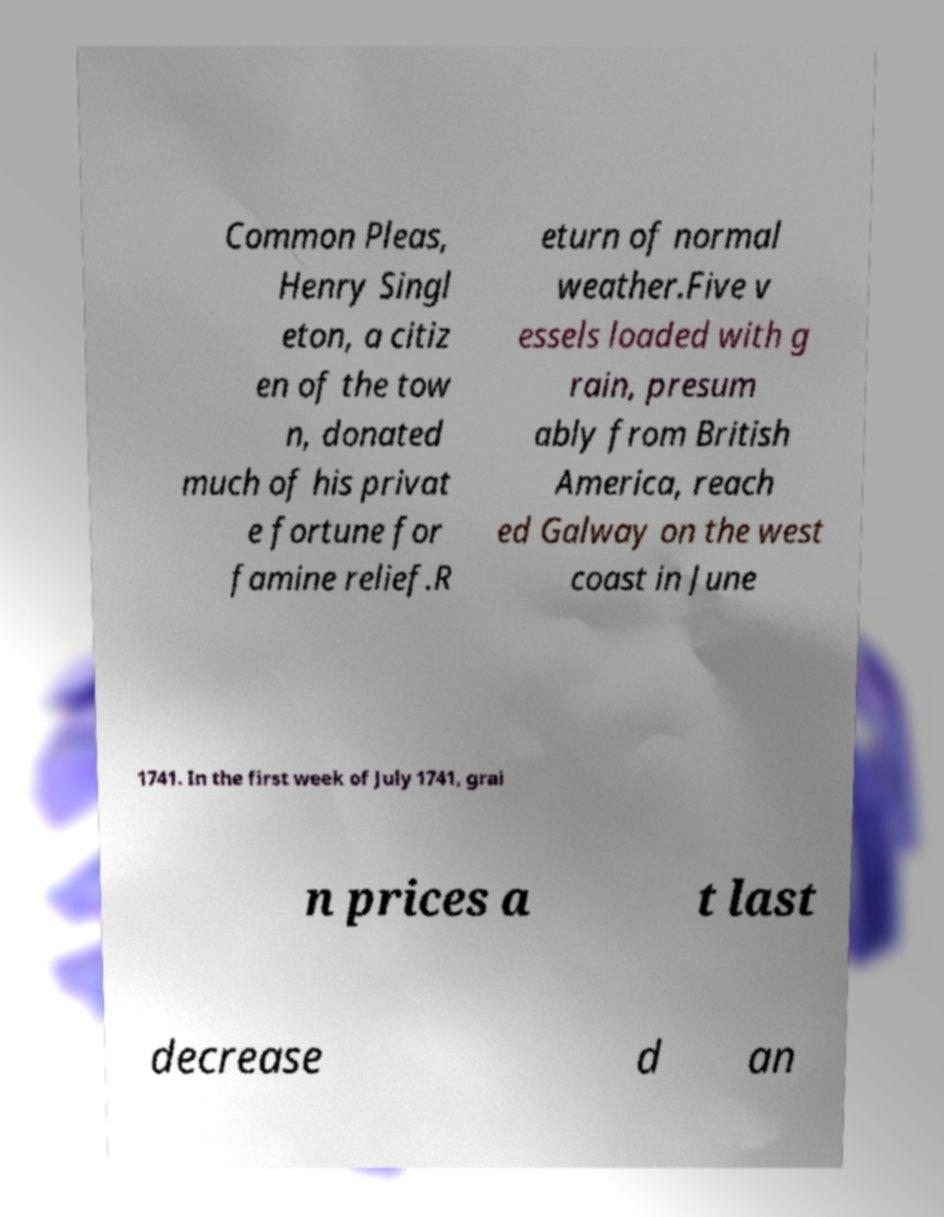Could you extract and type out the text from this image? Common Pleas, Henry Singl eton, a citiz en of the tow n, donated much of his privat e fortune for famine relief.R eturn of normal weather.Five v essels loaded with g rain, presum ably from British America, reach ed Galway on the west coast in June 1741. In the first week of July 1741, grai n prices a t last decrease d an 